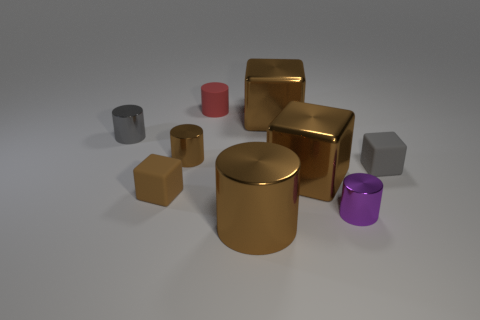Describe the color diversity among the objects. The objects in the image showcase a diversity of colors; including gold, gray, red, and purple. Most of the cubes have a gold finish, while the cylinders are gray, red, and purple. Do any two objects share the same color and shape? No, while some objects share the same color or shape, none of the objects have both the same color and shape. 